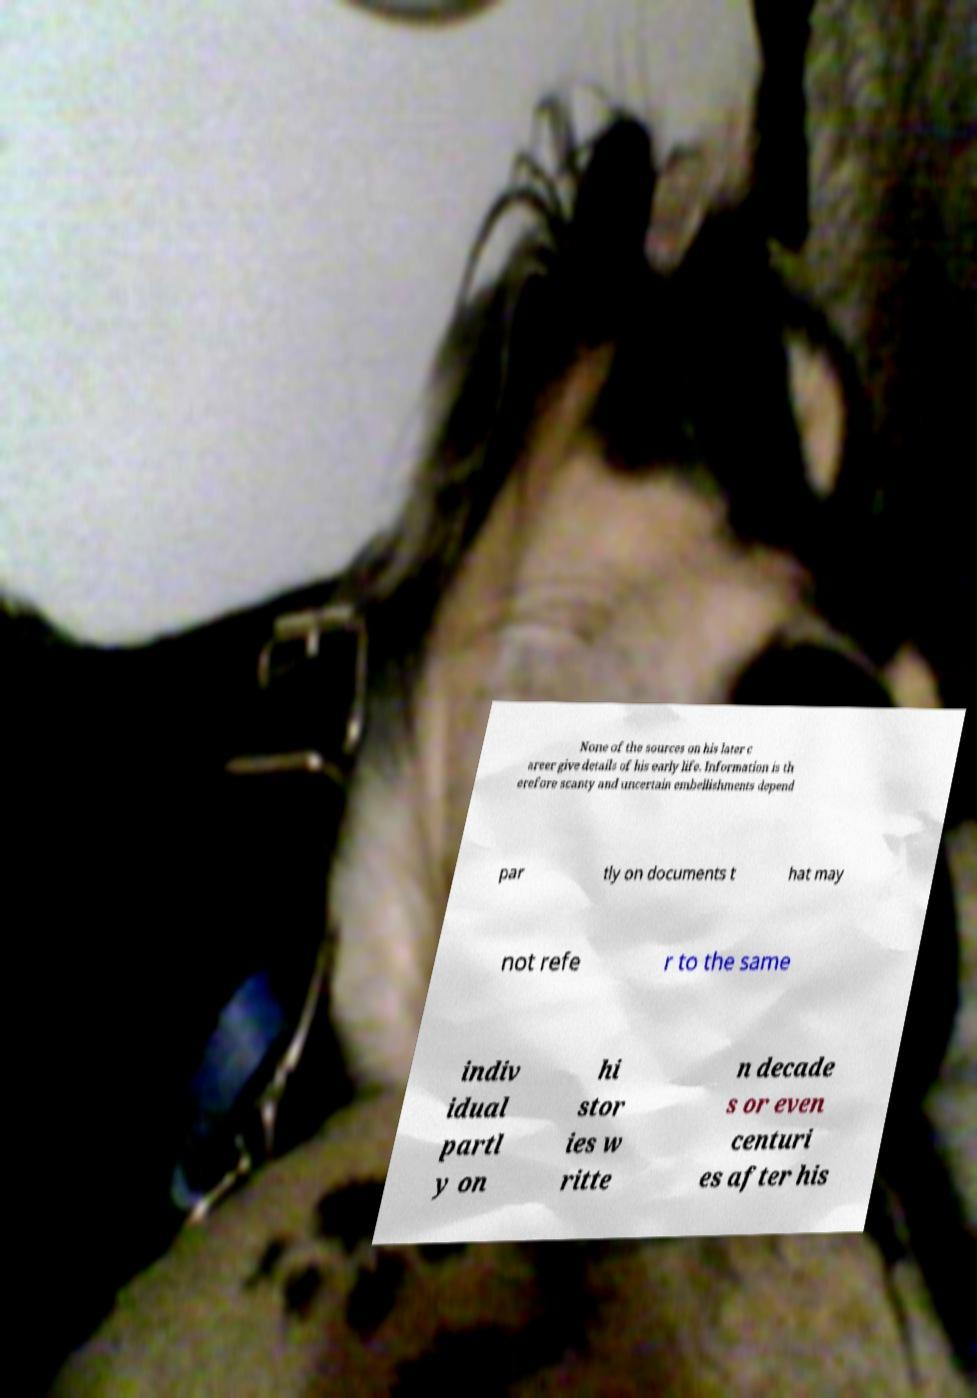What messages or text are displayed in this image? I need them in a readable, typed format. None of the sources on his later c areer give details of his early life. Information is th erefore scanty and uncertain embellishments depend par tly on documents t hat may not refe r to the same indiv idual partl y on hi stor ies w ritte n decade s or even centuri es after his 